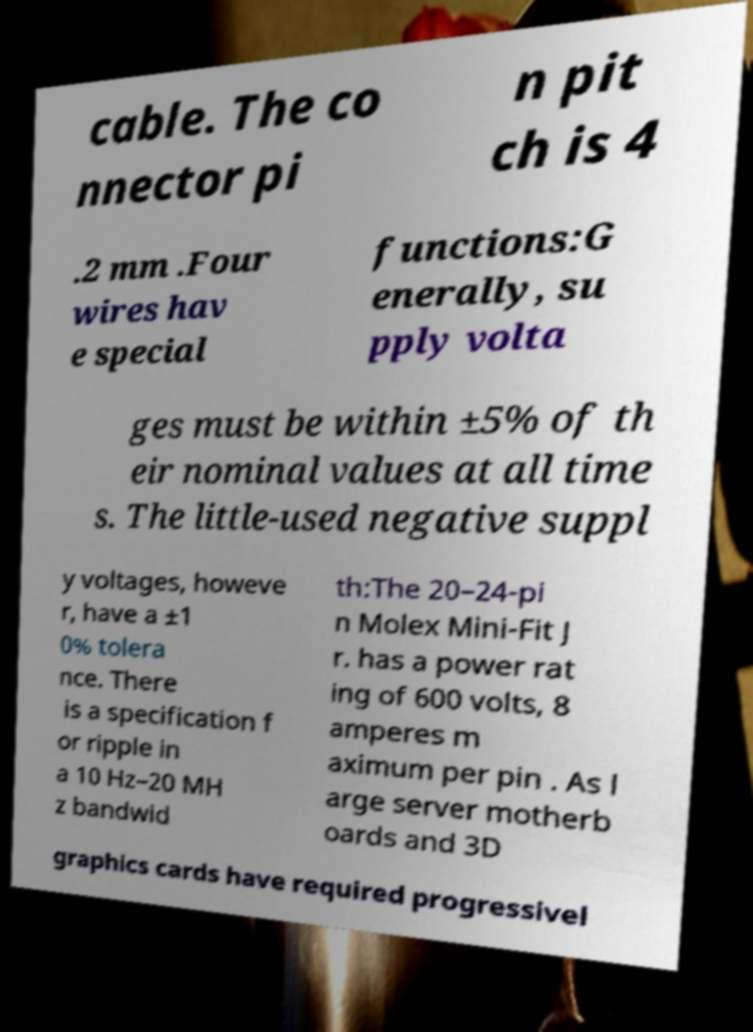Could you assist in decoding the text presented in this image and type it out clearly? cable. The co nnector pi n pit ch is 4 .2 mm .Four wires hav e special functions:G enerally, su pply volta ges must be within ±5% of th eir nominal values at all time s. The little-used negative suppl y voltages, howeve r, have a ±1 0% tolera nce. There is a specification f or ripple in a 10 Hz–20 MH z bandwid th:The 20–24-pi n Molex Mini-Fit J r. has a power rat ing of 600 volts, 8 amperes m aximum per pin . As l arge server motherb oards and 3D graphics cards have required progressivel 